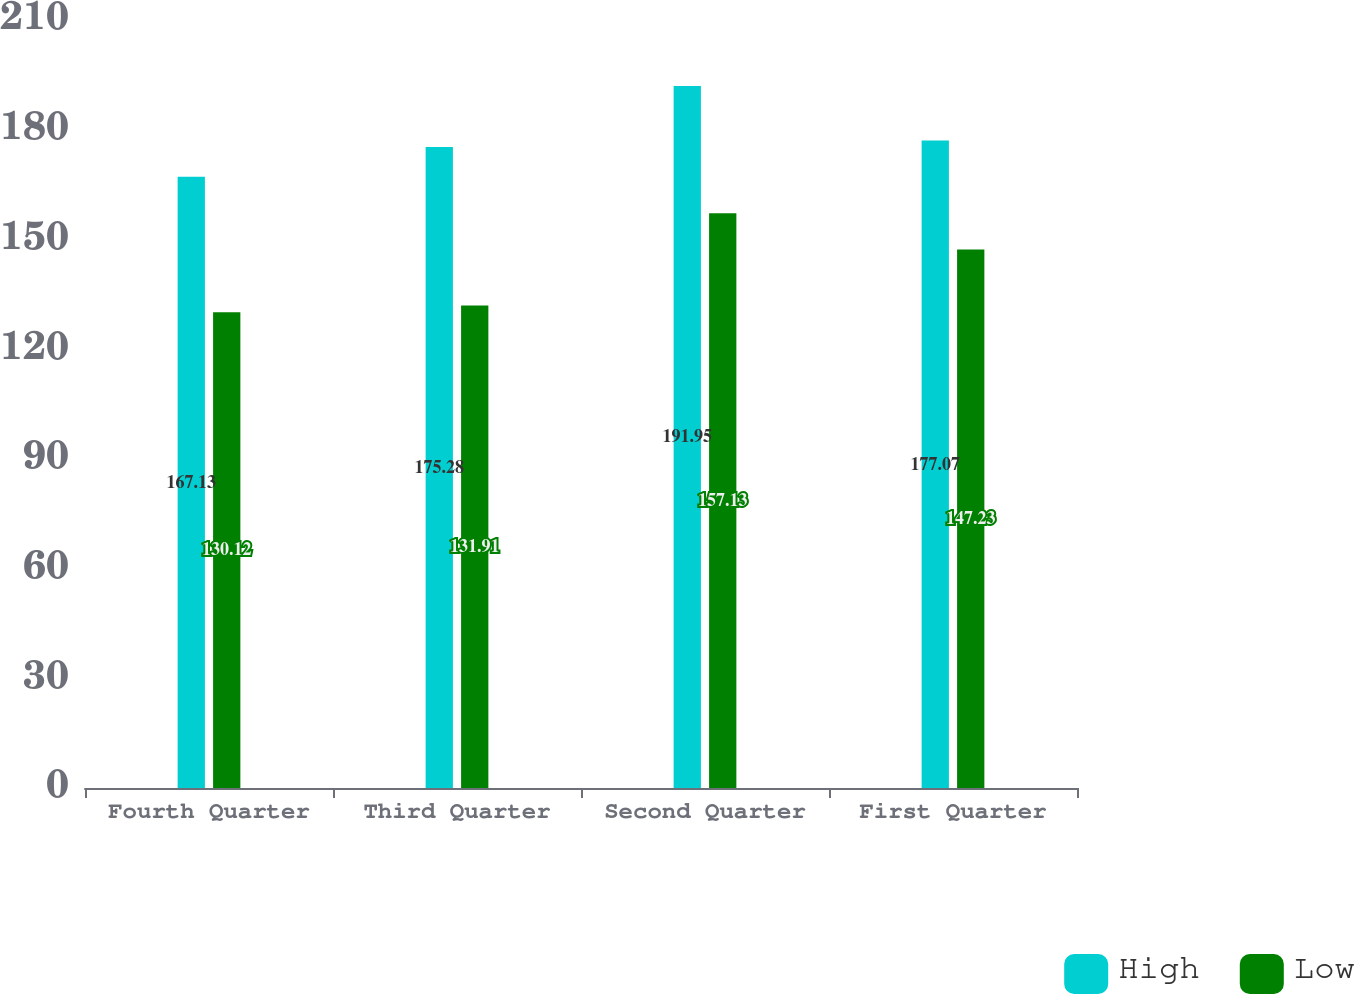Convert chart to OTSL. <chart><loc_0><loc_0><loc_500><loc_500><stacked_bar_chart><ecel><fcel>Fourth Quarter<fcel>Third Quarter<fcel>Second Quarter<fcel>First Quarter<nl><fcel>High<fcel>167.13<fcel>175.28<fcel>191.95<fcel>177.07<nl><fcel>Low<fcel>130.12<fcel>131.91<fcel>157.13<fcel>147.23<nl></chart> 